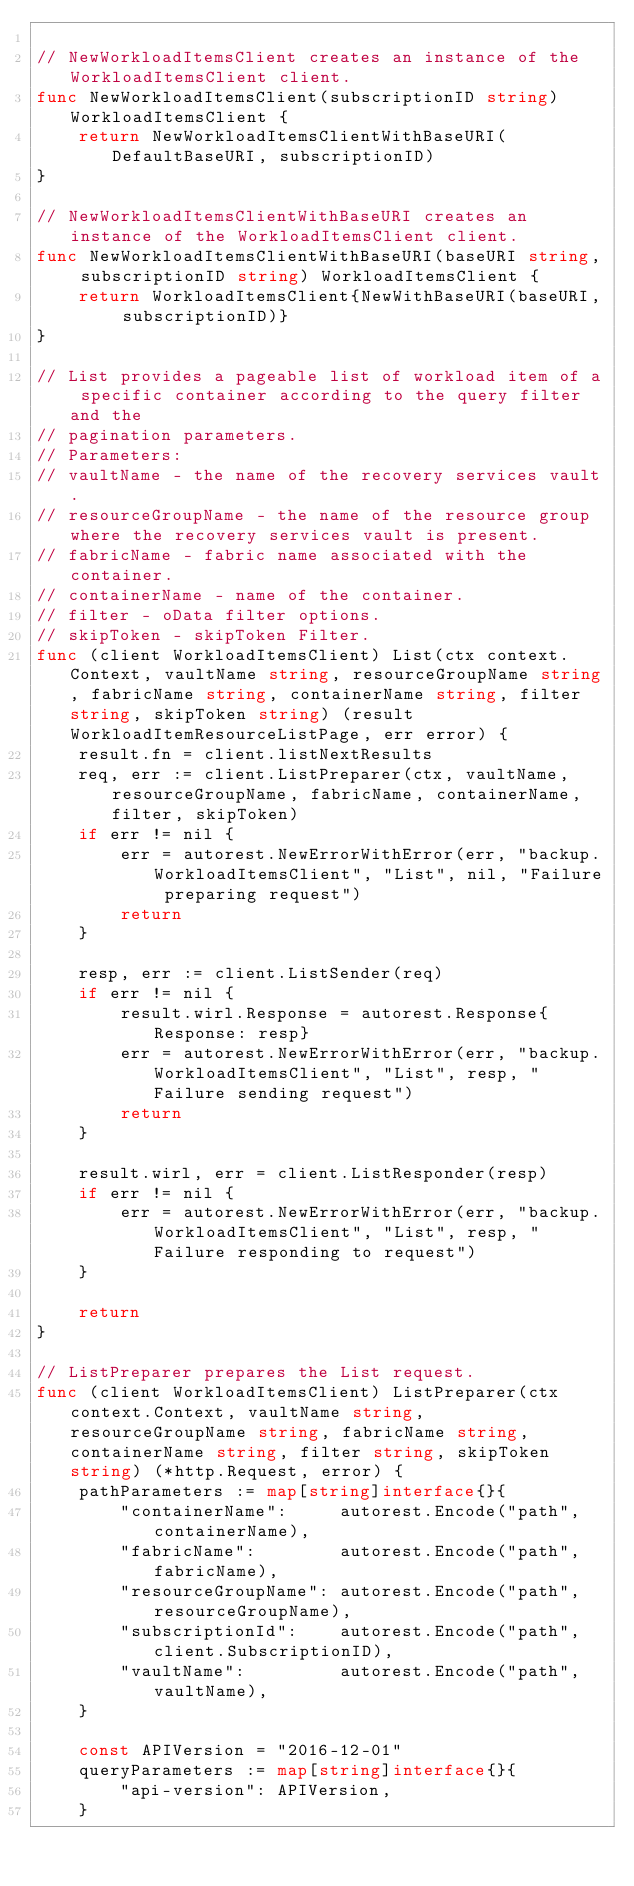Convert code to text. <code><loc_0><loc_0><loc_500><loc_500><_Go_>
// NewWorkloadItemsClient creates an instance of the WorkloadItemsClient client.
func NewWorkloadItemsClient(subscriptionID string) WorkloadItemsClient {
	return NewWorkloadItemsClientWithBaseURI(DefaultBaseURI, subscriptionID)
}

// NewWorkloadItemsClientWithBaseURI creates an instance of the WorkloadItemsClient client.
func NewWorkloadItemsClientWithBaseURI(baseURI string, subscriptionID string) WorkloadItemsClient {
	return WorkloadItemsClient{NewWithBaseURI(baseURI, subscriptionID)}
}

// List provides a pageable list of workload item of a specific container according to the query filter and the
// pagination parameters.
// Parameters:
// vaultName - the name of the recovery services vault.
// resourceGroupName - the name of the resource group where the recovery services vault is present.
// fabricName - fabric name associated with the container.
// containerName - name of the container.
// filter - oData filter options.
// skipToken - skipToken Filter.
func (client WorkloadItemsClient) List(ctx context.Context, vaultName string, resourceGroupName string, fabricName string, containerName string, filter string, skipToken string) (result WorkloadItemResourceListPage, err error) {
	result.fn = client.listNextResults
	req, err := client.ListPreparer(ctx, vaultName, resourceGroupName, fabricName, containerName, filter, skipToken)
	if err != nil {
		err = autorest.NewErrorWithError(err, "backup.WorkloadItemsClient", "List", nil, "Failure preparing request")
		return
	}

	resp, err := client.ListSender(req)
	if err != nil {
		result.wirl.Response = autorest.Response{Response: resp}
		err = autorest.NewErrorWithError(err, "backup.WorkloadItemsClient", "List", resp, "Failure sending request")
		return
	}

	result.wirl, err = client.ListResponder(resp)
	if err != nil {
		err = autorest.NewErrorWithError(err, "backup.WorkloadItemsClient", "List", resp, "Failure responding to request")
	}

	return
}

// ListPreparer prepares the List request.
func (client WorkloadItemsClient) ListPreparer(ctx context.Context, vaultName string, resourceGroupName string, fabricName string, containerName string, filter string, skipToken string) (*http.Request, error) {
	pathParameters := map[string]interface{}{
		"containerName":     autorest.Encode("path", containerName),
		"fabricName":        autorest.Encode("path", fabricName),
		"resourceGroupName": autorest.Encode("path", resourceGroupName),
		"subscriptionId":    autorest.Encode("path", client.SubscriptionID),
		"vaultName":         autorest.Encode("path", vaultName),
	}

	const APIVersion = "2016-12-01"
	queryParameters := map[string]interface{}{
		"api-version": APIVersion,
	}</code> 